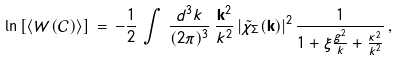Convert formula to latex. <formula><loc_0><loc_0><loc_500><loc_500>\ln \left [ \langle W ( { \mathcal { C } } ) \rangle \right ] \, = \, - \frac { 1 } { 2 } \, \int \, \frac { d ^ { 3 } k } { ( 2 \pi ) ^ { 3 } } \, \frac { { \mathbf k } ^ { 2 } } { k ^ { 2 } } \, | { \tilde { \chi } } _ { \Sigma } ( { \mathbf k } ) | ^ { 2 } \, \frac { 1 } { 1 + \xi \frac { g ^ { 2 } } { k } + \frac { \kappa ^ { 2 } } { k ^ { 2 } } } \, ,</formula> 